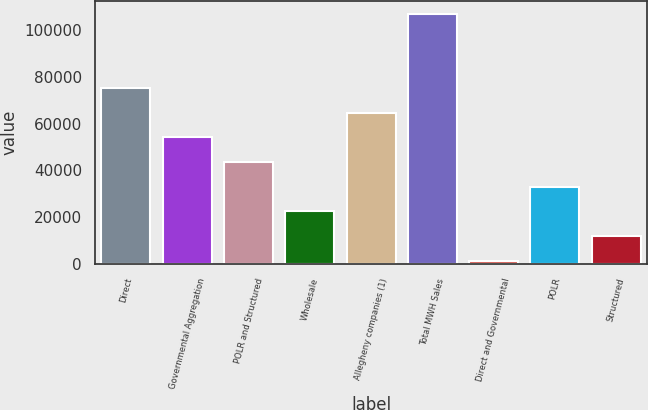Convert chart to OTSL. <chart><loc_0><loc_0><loc_500><loc_500><bar_chart><fcel>Direct<fcel>Governmental Aggregation<fcel>POLR and Structured<fcel>Wholesale<fcel>Allegheny companies (1)<fcel>Total MWH Sales<fcel>Direct and Governmental<fcel>POLR<fcel>Structured<nl><fcel>75244.9<fcel>54143.5<fcel>43592.8<fcel>22491.4<fcel>64694.2<fcel>106897<fcel>1390<fcel>33042.1<fcel>11940.7<nl></chart> 